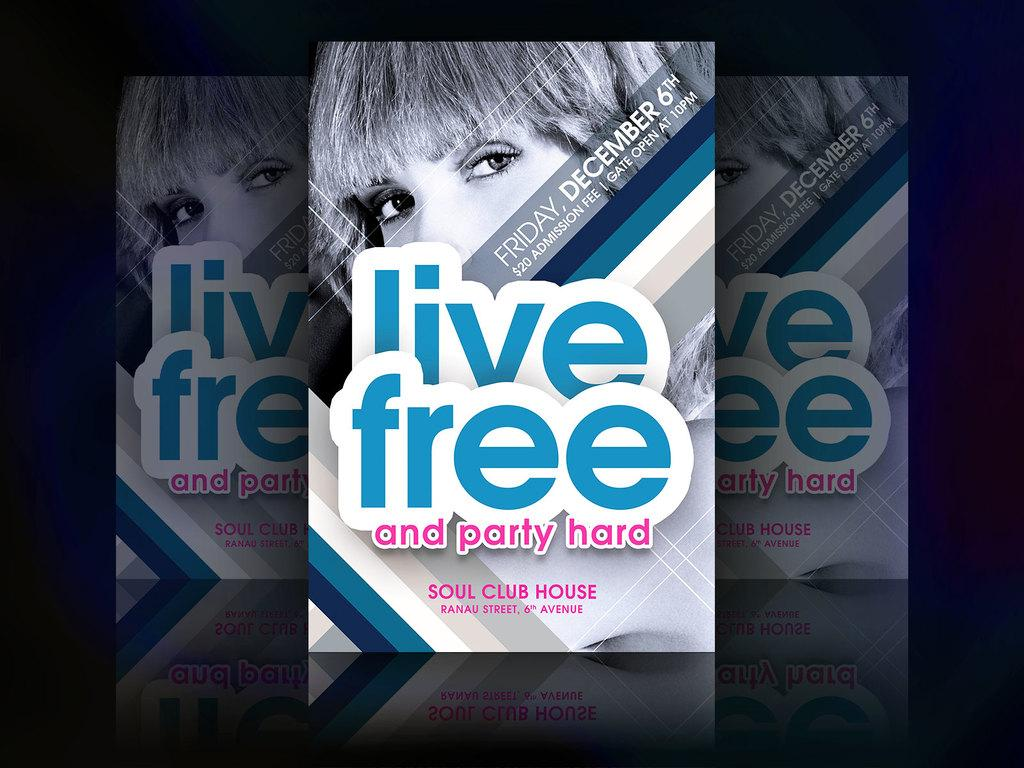<image>
Summarize the visual content of the image. A poster for a concert called live free and party hard. 